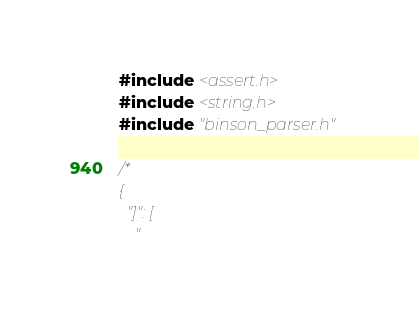Convert code to text. <code><loc_0><loc_0><loc_500><loc_500><_C_>#include <assert.h>
#include <string.h>
#include "binson_parser.h"

/*
{
  "]": [
    "</code> 